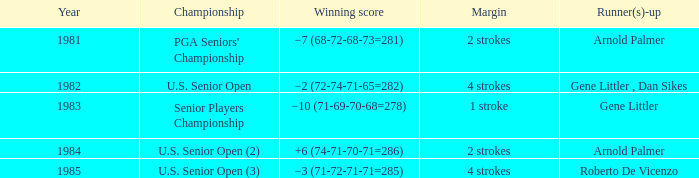Give me the full table as a dictionary. {'header': ['Year', 'Championship', 'Winning score', 'Margin', 'Runner(s)-up'], 'rows': [['1981', "PGA Seniors' Championship", '−7 (68-72-68-73=281)', '2 strokes', 'Arnold Palmer'], ['1982', 'U.S. Senior Open', '−2 (72-74-71-65=282)', '4 strokes', 'Gene Littler , Dan Sikes'], ['1983', 'Senior Players Championship', '−10 (71-69-70-68=278)', '1 stroke', 'Gene Littler'], ['1984', 'U.S. Senior Open (2)', '+6 (74-71-70-71=286)', '2 strokes', 'Arnold Palmer'], ['1985', 'U.S. Senior Open (3)', '−3 (71-72-71-71=285)', '4 strokes', 'Roberto De Vicenzo']]} What championship was in 1985? U.S. Senior Open (3). 